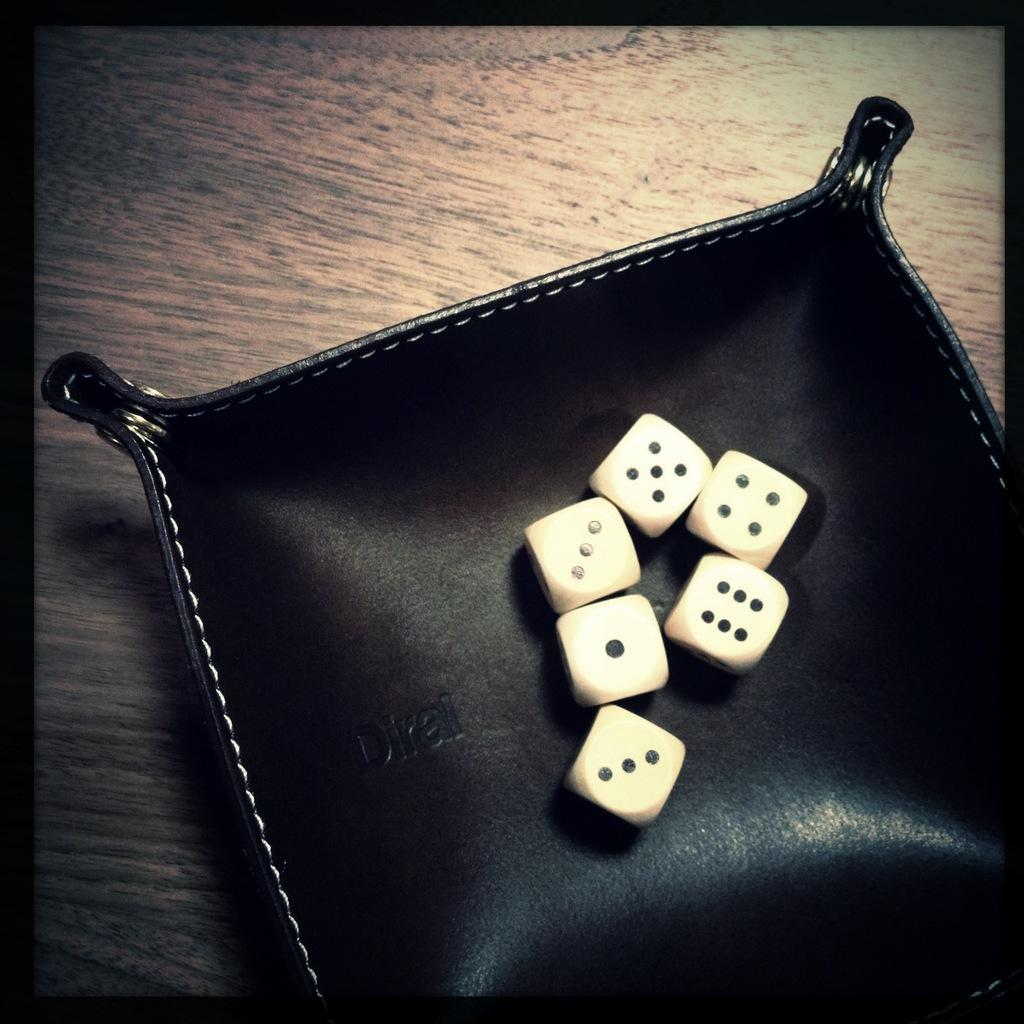How many dices are visible in the image? There are six dices in the image. What is the color of the object on which the dices are placed? The dices are placed on a black color object. What type of bun is being used as a prop in the image? There is no bun present in the image; it only features six dices placed on a black object. 